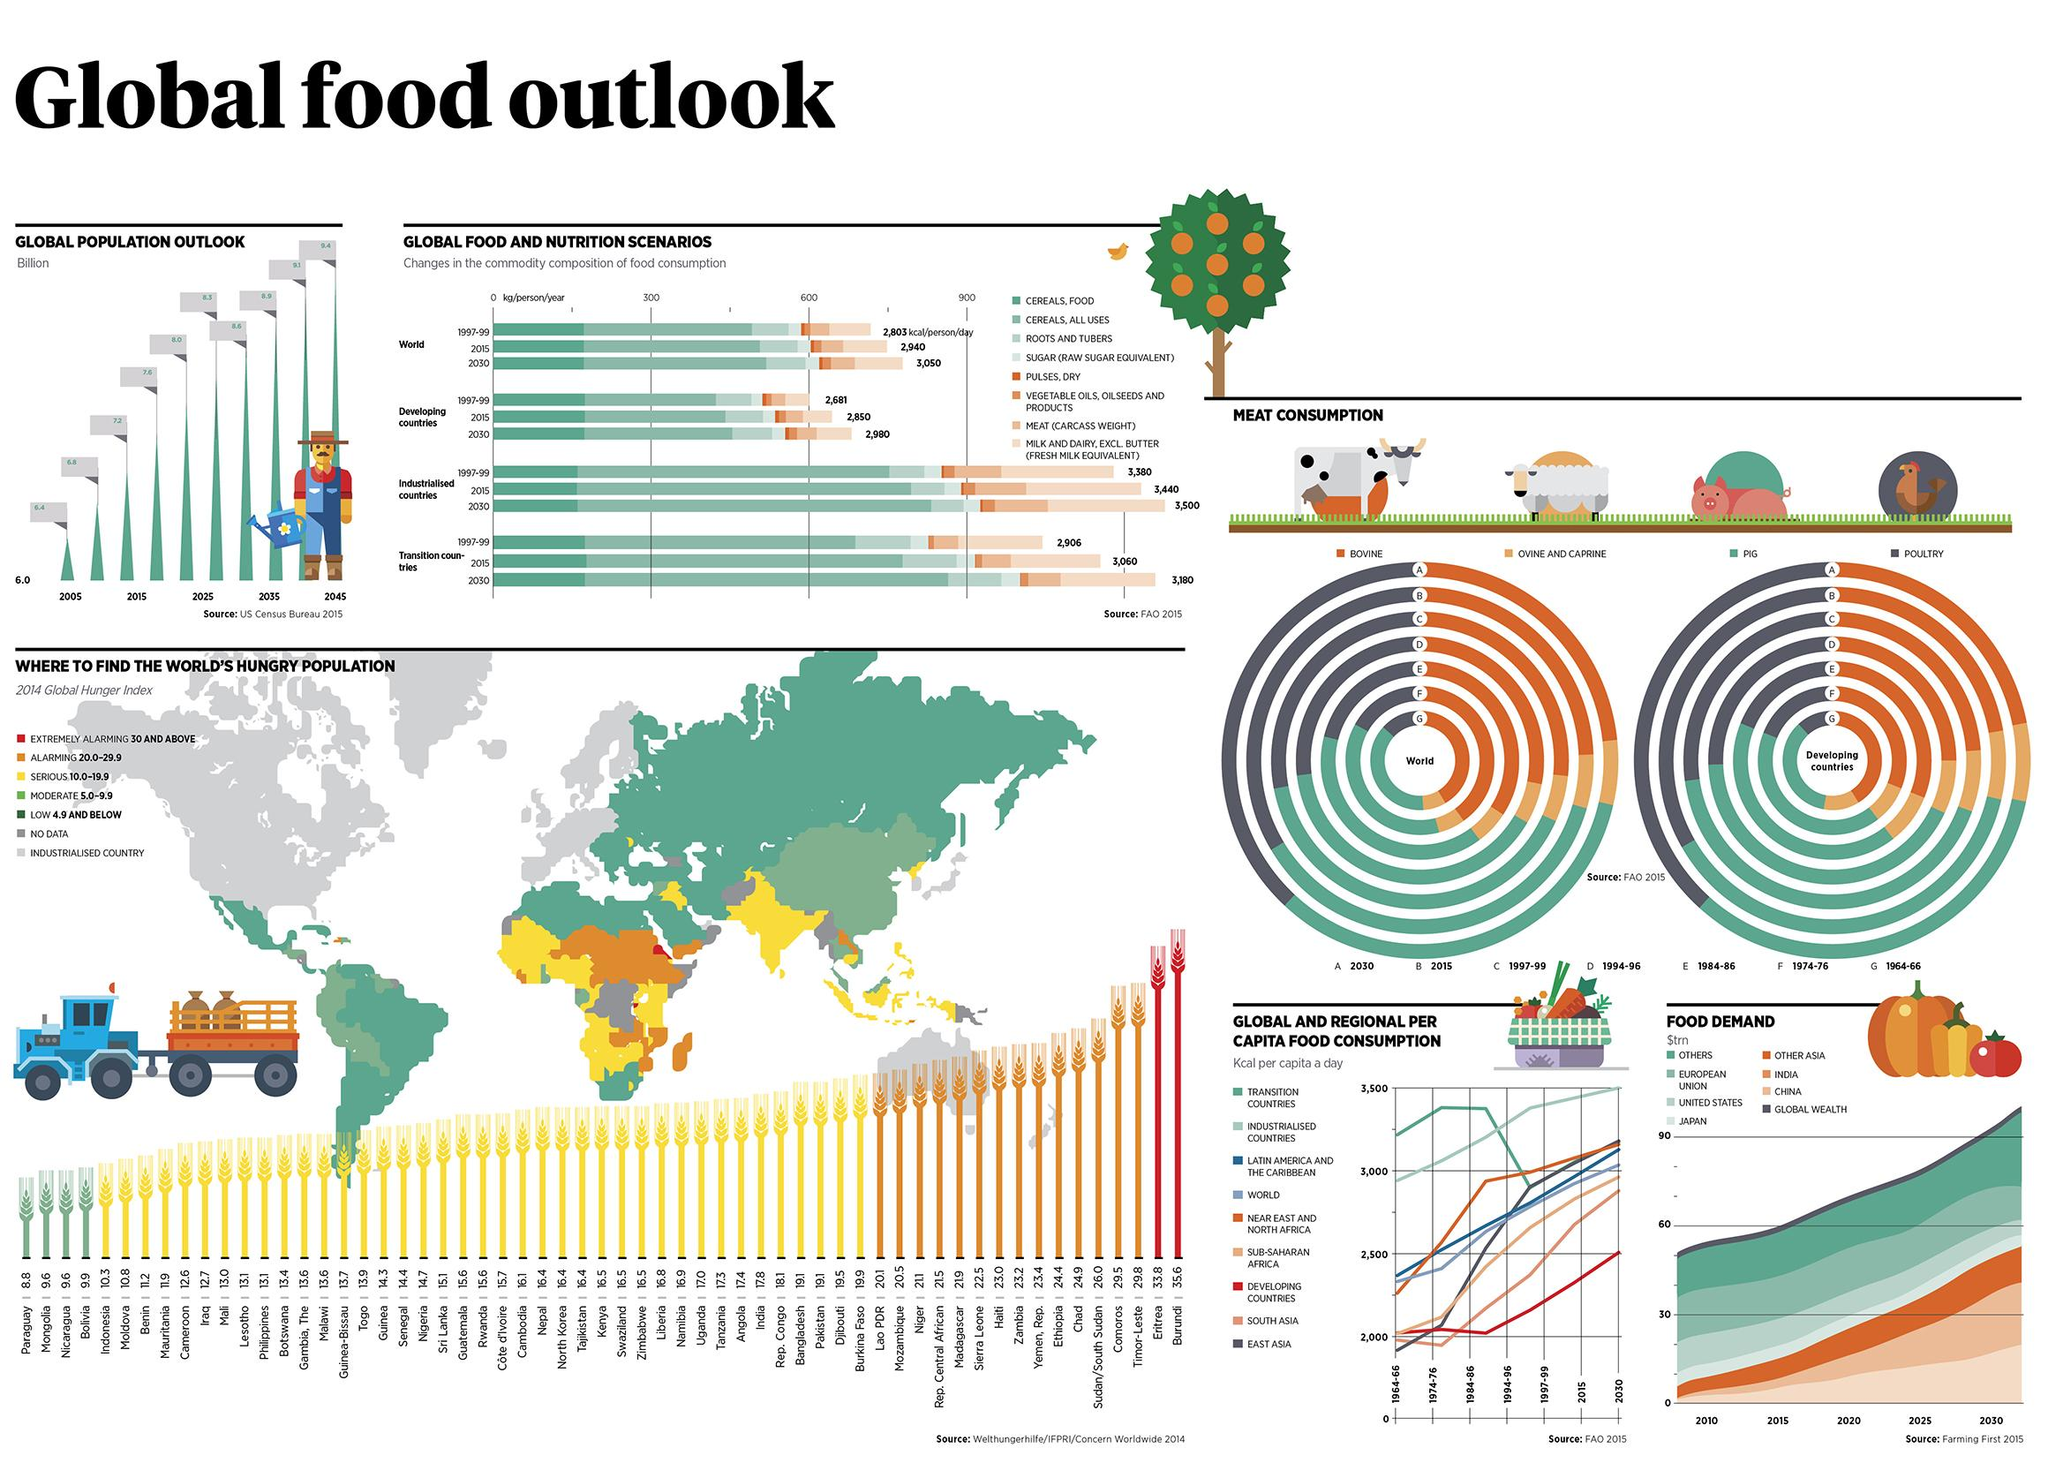Give some essential details in this illustration. Eritrea and Burundi have alarmingly high rates of hunger. By 2030, a person in an industrialized country is projected to consume an average of 520 additional calories per day, while a person in a developing country is expected to consume fewer calories compared to their counterparts in an industrialized country. By 2030, the predicted increase in food consumption in transition countries is expected to reach 274 KCal per person per day, compared to the 1999 level of 199 KCal per person per day. In countries undergoing transition, there is a significant decline in the number of calories consumed per capita per day, indicating a significant challenge in meeting basic nutritional needs. 